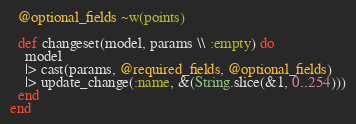<code> <loc_0><loc_0><loc_500><loc_500><_Elixir_>  @optional_fields ~w(points)

  def changeset(model, params \\ :empty) do
    model
    |> cast(params, @required_fields, @optional_fields)
    |> update_change(:name, &(String.slice(&1, 0..254)))
  end
end
</code> 